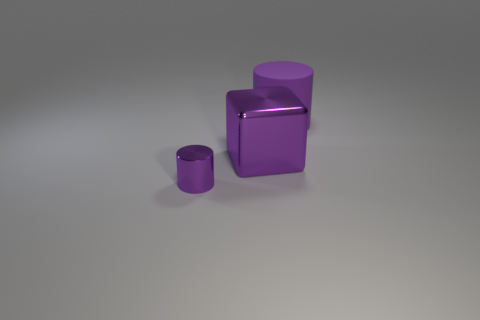Is there anything else that has the same material as the big cylinder?
Your response must be concise. No. Are there any other things that have the same size as the metallic cylinder?
Your response must be concise. No. There is another object that is the same shape as the big rubber thing; what material is it?
Offer a very short reply. Metal. The large purple thing that is in front of the big object that is to the right of the purple metal object that is behind the tiny purple metallic thing is what shape?
Ensure brevity in your answer.  Cube. What material is the tiny thing that is the same color as the large matte cylinder?
Offer a very short reply. Metal. What number of tiny yellow metal objects are the same shape as the purple matte thing?
Your answer should be very brief. 0. Is the color of the metallic thing behind the small object the same as the large object behind the large purple metal block?
Provide a succinct answer. Yes. There is a object that is the same size as the purple block; what material is it?
Provide a short and direct response. Rubber. Are there any gray objects that have the same size as the purple rubber cylinder?
Offer a very short reply. No. Is the number of small purple metallic cylinders right of the large shiny object less than the number of tiny purple metallic cylinders?
Make the answer very short. Yes. 